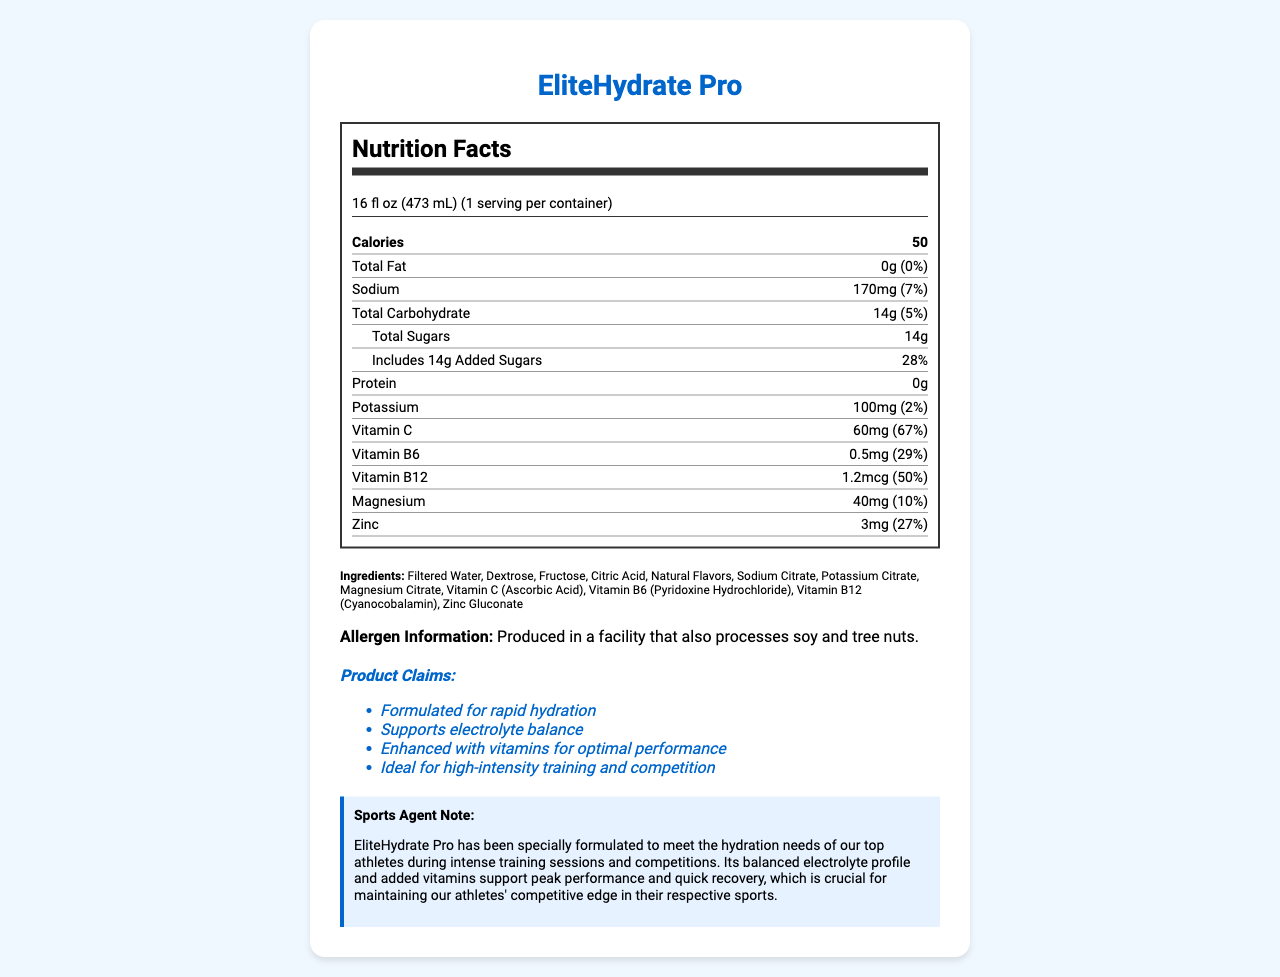what is the serving size of EliteHydrate Pro? This information is located at the top of the Nutrition Facts section of the document.
Answer: 16 fl oz (473 mL) how many calories are in one serving of EliteHydrate Pro? The calories per serving are listed prominently in the Nutrition Facts section.
Answer: 50 how much sodium does one serving of EliteHydrate Pro contain? The amount of sodium per serving is specified in the Nutrition Facts label.
Answer: 170mg what percentage of the daily value of Magnesium is in a serving of EliteHydrate Pro? The daily value percentage for Magnesium is listed next to the amount in the Nutrition Facts section.
Answer: 10% how much Vitamin C is in EliteHydrate Pro? The amount of Vitamin C per serving is provided in the Nutrition Facts section.
Answer: 60mg which of the following ingredients is not in EliteHydrate Pro? A. Dextrose B. Sodium Citrate C. High Fructose Corn Syrup D. Citric Acid High Fructose Corn Syrup is not listed in the ingredients section.
Answer: C what is the main claim made about EliteHydrate Pro? A. Weight Loss B. Rapid Hydration C. Muscle Gain D. Increased Energy The document states that EliteHydrate Pro is formulated for rapid hydration.
Answer: B can EliteHydrate Pro be considered a good source of protein? The Nutrition Facts label indicates that EliteHydrate Pro contains 0g of protein per serving.
Answer: No summarize the purpose and benefits of EliteHydrate Pro as described in the document. The document outlines the specific nutrients and benefits, emphasizing the product's formulation for top athletes.
Answer: EliteHydrate Pro is a vitamin-fortified sports drink designed to prevent dehydration during intense training and competitions. It contains electrolytes and vitamins that support hydration, electrolyte balance, and optimal performance. does EliteHydrate Pro contain any common allergens? The allergen information states this point in the document.
Answer: It is produced in a facility that also processes soy and tree nuts. how many grams of sugar does EliteHydrate Pro contain per serving? The total amount of sugar is listed in the Nutrition Facts label.
Answer: 14g is there enough information to determine if EliteHydrate Pro contains caffeine? The document does not provide any information about caffeine content.
Answer: No how much added sugar is in one serving of EliteHydrate Pro? The Nutrition Facts section specifies the amount of added sugars.
Answer: 14g how many daily values are provided for vitamins and minerals in the Nutrition Facts section? These values are clearly listed in the Nutrition Facts section.
Answer: 6 (Vitamin C, Vitamin B6, Vitamin B12, Potassium, Magnesium, Zinc) 